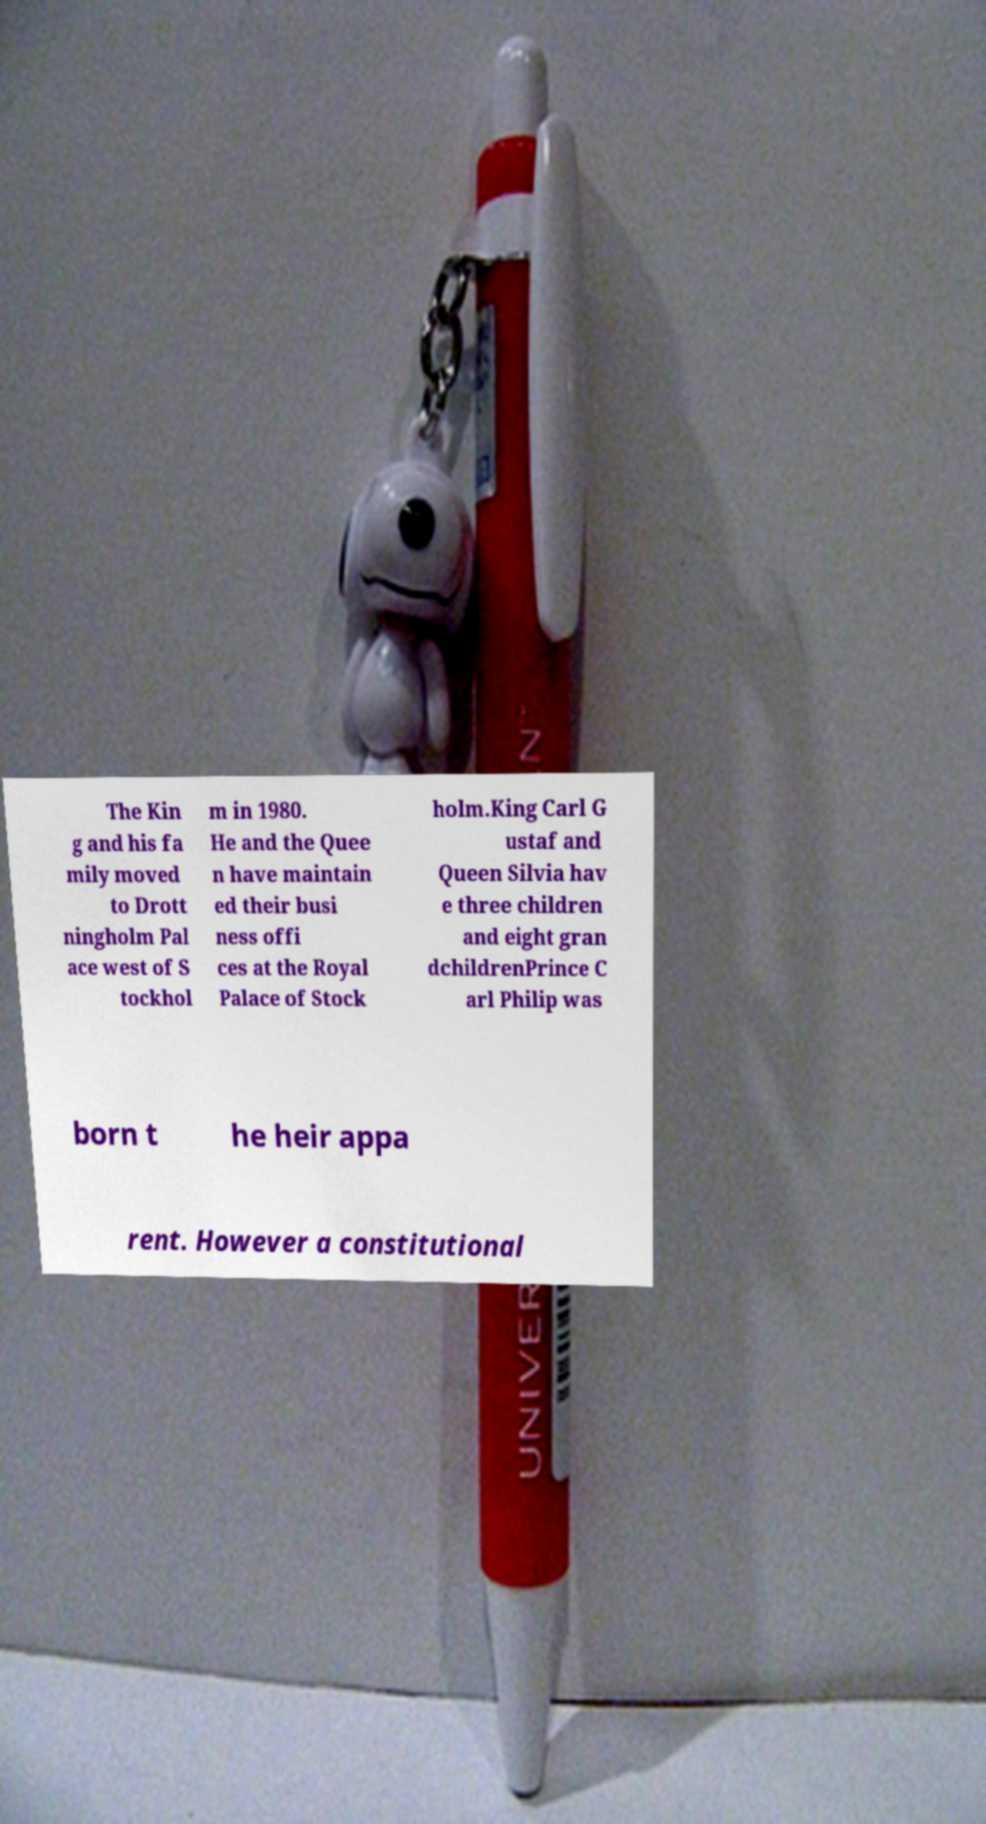Could you assist in decoding the text presented in this image and type it out clearly? The Kin g and his fa mily moved to Drott ningholm Pal ace west of S tockhol m in 1980. He and the Quee n have maintain ed their busi ness offi ces at the Royal Palace of Stock holm.King Carl G ustaf and Queen Silvia hav e three children and eight gran dchildrenPrince C arl Philip was born t he heir appa rent. However a constitutional 